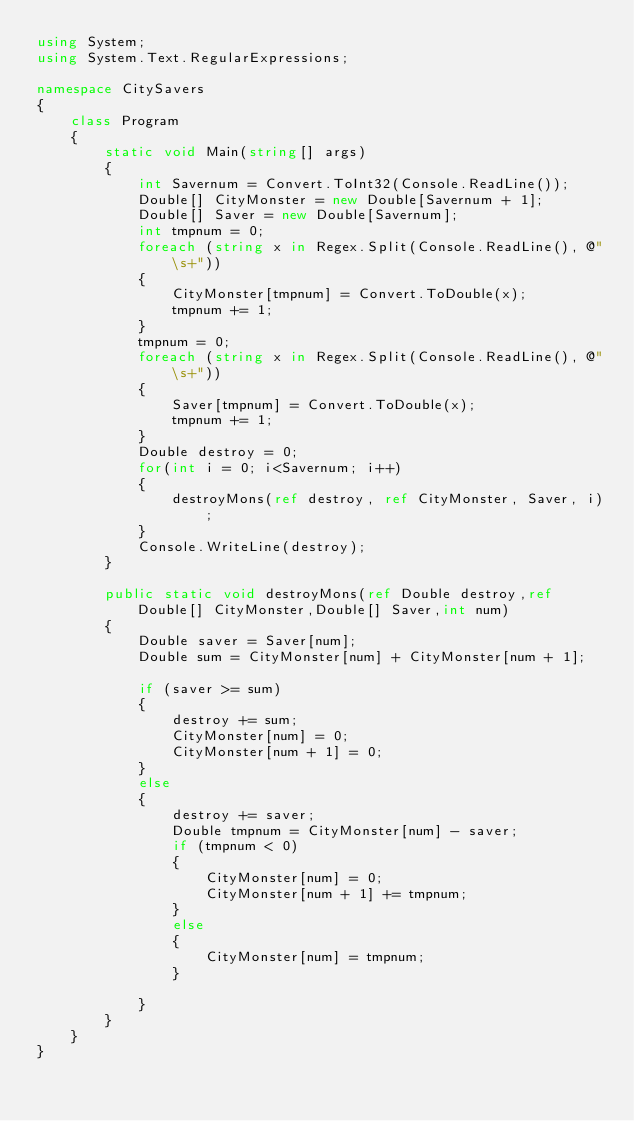<code> <loc_0><loc_0><loc_500><loc_500><_C#_>using System;
using System.Text.RegularExpressions;

namespace CitySavers
{
    class Program
    {
        static void Main(string[] args)
        {
            int Savernum = Convert.ToInt32(Console.ReadLine());
            Double[] CityMonster = new Double[Savernum + 1];
            Double[] Saver = new Double[Savernum];
            int tmpnum = 0;
            foreach (string x in Regex.Split(Console.ReadLine(), @"\s+"))
            {
                CityMonster[tmpnum] = Convert.ToDouble(x);
                tmpnum += 1;
            }
            tmpnum = 0;
            foreach (string x in Regex.Split(Console.ReadLine(), @"\s+"))
            {
                Saver[tmpnum] = Convert.ToDouble(x);
                tmpnum += 1;
            }
            Double destroy = 0;
            for(int i = 0; i<Savernum; i++)
            {
                destroyMons(ref destroy, ref CityMonster, Saver, i);
            }
            Console.WriteLine(destroy);
        }

        public static void destroyMons(ref Double destroy,ref Double[] CityMonster,Double[] Saver,int num)
        {
            Double saver = Saver[num];
            Double sum = CityMonster[num] + CityMonster[num + 1];

            if (saver >= sum)
            {
                destroy += sum;
                CityMonster[num] = 0;
                CityMonster[num + 1] = 0;
            }
            else
            {
                destroy += saver;
                Double tmpnum = CityMonster[num] - saver;
                if (tmpnum < 0)
                {
                    CityMonster[num] = 0;
                    CityMonster[num + 1] += tmpnum;
                }
                else
                {
                    CityMonster[num] = tmpnum;
                }
                
            }
        }
    }
}
</code> 